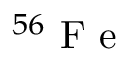<formula> <loc_0><loc_0><loc_500><loc_500>^ { 5 6 } F e</formula> 